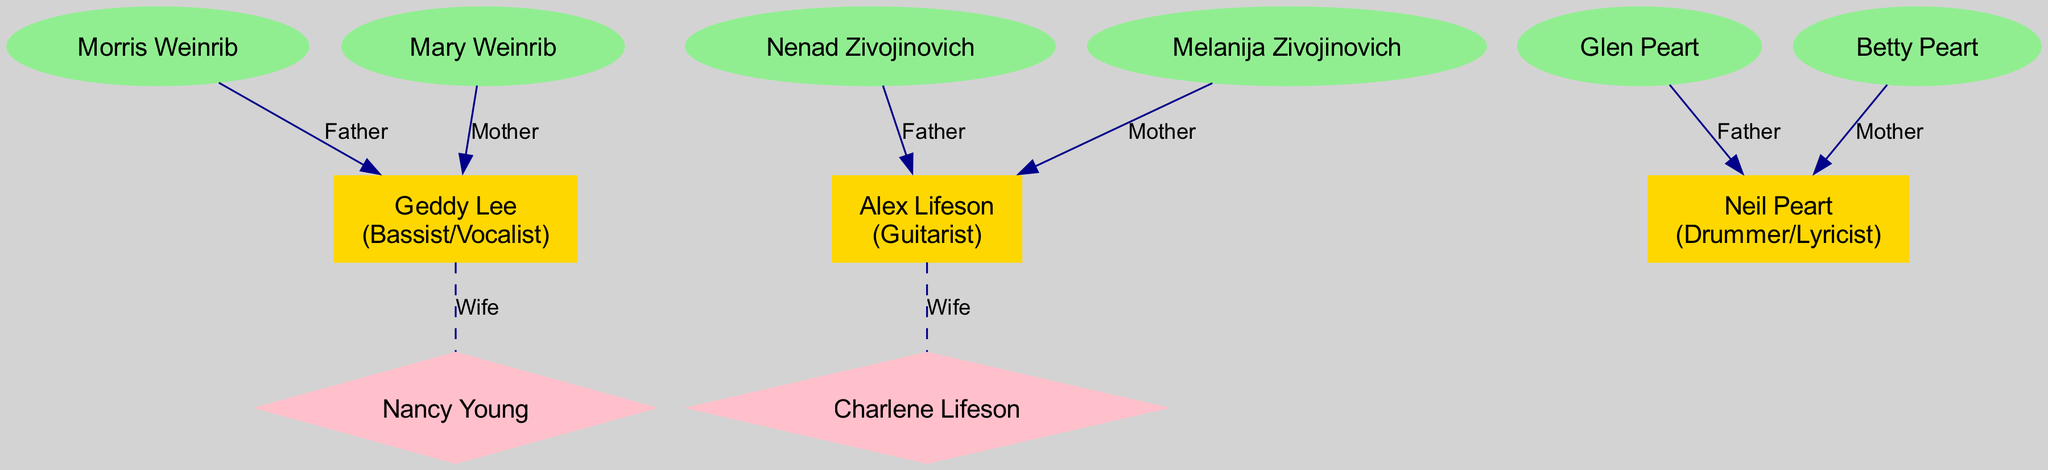What is Geddy Lee's role in the band Rush? Geddy Lee is identified in the diagram with the role of "Bassist/Vocalist." This information is presented within the box that represents Geddy Lee.
Answer: Bassist/Vocalist Who is Alex Lifeson's wife? The diagram specifies the relationship between Alex Lifeson and Charlene Lifeson, indicating that Charlene Lifeson is his wife, connected by a dashed line labeled "Wife."
Answer: Charlene Lifeson How many parents does Neil Peart have listed in the diagram? The diagram shows two parents for Neil Peart: Glen Peart and Betty Peart. Each is represented with an ellipse shape connected to Neil Peart with a line labeled "Father" and "Mother," respectively.
Answer: 2 What type of connection is represented between Geddy Lee and Nancy Young? The relationship between Geddy Lee and Nancy Young is represented as a dashed line labeled "Wife," indicating a marital connection. This relationship is depicted as a diamond shape for Nancy Young.
Answer: Wife List one parent of Alex Lifeson. In the diagram, it is shown that Alex Lifeson has a father named Nenad Zivojinovich, connected with a direct line labeled "Father."
Answer: Nenad Zivojinovich Which member of Rush has the most family connections shown in the diagram? By reviewing the total number of connections for each band member, it becomes evident that Geddy Lee has the most connections, including relationships with both parents and his wife.
Answer: Geddy Lee How many members are in the band Rush according to the diagram? The diagram explicitly lists three members: Geddy Lee, Alex Lifeson, and Neil Peart, all of whom are connected to their respective family members.
Answer: 3 Who is the mother of Geddy Lee? The diagram indicates that Geddy Lee's mother is Mary Weinrib, connected directly to him with a line labeled "Mother."
Answer: Mary Weinrib What color is used to represent the spouses in the diagram? The diagram uses pink for the ellipses representing spouses like Nancy Young and Charlene Lifeson, which are differentiated from other family relationships.
Answer: Pink 